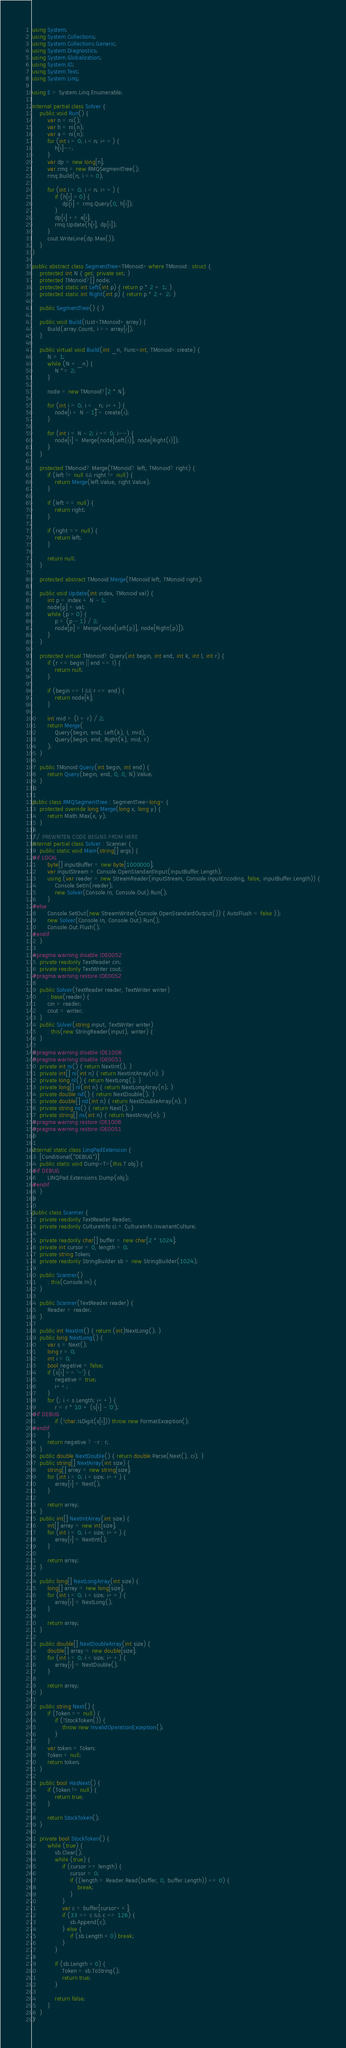<code> <loc_0><loc_0><loc_500><loc_500><_C#_>using System;
using System.Collections;
using System.Collections.Generic;
using System.Diagnostics;
using System.Globalization;
using System.IO;
using System.Text;
using System.Linq;

using E = System.Linq.Enumerable;

internal partial class Solver {
    public void Run() {
        var n = ni();
        var h = ni(n);
        var a = ni(n);
        for (int i = 0; i < n; i++) {
            h[i]--;
        }
        var dp = new long[n];
        var rmq = new RMQSegmentTree();
        rmq.Build(n, i => 0);

        for (int i = 0; i < n; i++) {
            if (h[i] > 0) {
                dp[i] = rmq.Query(0, h[i]);
            }
            dp[i] += a[i];
            rmq.Update(h[i], dp[i]);
        }
        cout.WriteLine(dp.Max());
    }
}

public abstract class SegmentTree<TMonoid> where TMonoid : struct {
    protected int N { get; private set; }
    protected TMonoid?[] node;
    protected static int Left(int p) { return p * 2 + 1; }
    protected static int Right(int p) { return p * 2 + 2; }

    public SegmentTree() { }

    public void Build(IList<TMonoid> array) {
        Build(array.Count, i => array[i]);
    }

    public virtual void Build(int _n, Func<int, TMonoid> create) {
        N = 1;
        while (N < _n) {
            N *= 2;
        }

        node = new TMonoid?[2 * N];

        for (int i = 0; i < _n; i++) {
            node[i + N - 1] = create(i);
        }

        for (int i = N - 2; i >= 0; i--) {
            node[i] = Merge(node[Left(i)], node[Right(i)]);
        }
    }

    protected TMonoid? Merge(TMonoid? left, TMonoid? right) {
        if (left != null && right != null) {
            return Merge(left.Value, right.Value);
        }

        if (left == null) {
            return right;
        }

        if (right == null) {
            return left;
        }

        return null;
    }

    protected abstract TMonoid Merge(TMonoid left, TMonoid right);

    public void Update(int index, TMonoid val) {
        int p = index + N - 1;
        node[p] = val;
        while (p > 0) {
            p = (p - 1) / 2;
            node[p] = Merge(node[Left(p)], node[Right(p)]);
        }
    }

    protected virtual TMonoid? Query(int begin, int end, int k, int l, int r) {
        if (r <= begin || end <= l) {
            return null;
        }

        if (begin <= l && r <= end) {
            return node[k];
        }

        int mid = (l + r) / 2;
        return Merge(
            Query(begin, end, Left(k), l, mid),
            Query(begin, end, Right(k), mid, r)
        );
    }

    public TMonoid Query(int begin, int end) {
        return Query(begin, end, 0, 0, N).Value;
    }
};

public class RMQSegmentTree : SegmentTree<long> {
    protected override long Merge(long x, long y) {
        return Math.Max(x, y);
    }
}
// PREWRITEN CODE BEGINS FROM HERE
internal partial class Solver : Scanner {
    public static void Main(string[] args) {
#if LOCAL
        byte[] inputBuffer = new byte[1000000];
        var inputStream = Console.OpenStandardInput(inputBuffer.Length);
        using (var reader = new StreamReader(inputStream, Console.InputEncoding, false, inputBuffer.Length)) {
            Console.SetIn(reader);
            new Solver(Console.In, Console.Out).Run();
        }
#else
        Console.SetOut(new StreamWriter(Console.OpenStandardOutput()) { AutoFlush = false });
        new Solver(Console.In, Console.Out).Run();
        Console.Out.Flush();
#endif
    }

#pragma warning disable IDE0052
    private readonly TextReader cin;
    private readonly TextWriter cout;
#pragma warning restore IDE0052

    public Solver(TextReader reader, TextWriter writer)
        : base(reader) {
        cin = reader;
        cout = writer;
    }
    public Solver(string input, TextWriter writer)
        : this(new StringReader(input), writer) {
    }

#pragma warning disable IDE1006
#pragma warning disable IDE0051
    private int ni() { return NextInt(); }
    private int[] ni(int n) { return NextIntArray(n); }
    private long nl() { return NextLong(); }
    private long[] nl(int n) { return NextLongArray(n); }
    private double nd() { return NextDouble(); }
    private double[] nd(int n) { return NextDoubleArray(n); }
    private string ns() { return Next(); }
    private string[] ns(int n) { return NextArray(n); }
#pragma warning restore IDE1006
#pragma warning restore IDE0051
}

internal static class LinqPadExtension {
    [Conditional("DEBUG")]
    public static void Dump<T>(this T obj) {
#if DEBUG
        LINQPad.Extensions.Dump(obj);
#endif
    }
}

public class Scanner {
    private readonly TextReader Reader;
    private readonly CultureInfo ci = CultureInfo.InvariantCulture;

    private readonly char[] buffer = new char[2 * 1024];
    private int cursor = 0, length = 0;
    private string Token;
    private readonly StringBuilder sb = new StringBuilder(1024);

    public Scanner()
        : this(Console.In) {
    }

    public Scanner(TextReader reader) {
        Reader = reader;
    }

    public int NextInt() { return (int)NextLong(); }
    public long NextLong() {
        var s = Next();
        long r = 0;
        int i = 0;
        bool negative = false;
        if (s[i] == '-') {
            negative = true;
            i++;
        }
        for (; i < s.Length; i++) {
            r = r * 10 + (s[i] - '0');
#if DEBUG
            if (!char.IsDigit(s[i])) throw new FormatException();
#endif
        }
        return negative ? -r : r;
    }
    public double NextDouble() { return double.Parse(Next(), ci); }
    public string[] NextArray(int size) {
        string[] array = new string[size];
        for (int i = 0; i < size; i++) {
            array[i] = Next();
        }

        return array;
    }
    public int[] NextIntArray(int size) {
        int[] array = new int[size];
        for (int i = 0; i < size; i++) {
            array[i] = NextInt();
        }

        return array;
    }

    public long[] NextLongArray(int size) {
        long[] array = new long[size];
        for (int i = 0; i < size; i++) {
            array[i] = NextLong();
        }

        return array;
    }

    public double[] NextDoubleArray(int size) {
        double[] array = new double[size];
        for (int i = 0; i < size; i++) {
            array[i] = NextDouble();
        }

        return array;
    }

    public string Next() {
        if (Token == null) {
            if (!StockToken()) {
                throw new InvalidOperationException();
            }
        }
        var token = Token;
        Token = null;
        return token;
    }

    public bool HasNext() {
        if (Token != null) {
            return true;
        }

        return StockToken();
    }

    private bool StockToken() {
        while (true) {
            sb.Clear();
            while (true) {
                if (cursor >= length) {
                    cursor = 0;
                    if ((length = Reader.Read(buffer, 0, buffer.Length)) <= 0) {
                        break;
                    }
                }
                var c = buffer[cursor++];
                if (33 <= c && c <= 126) {
                    sb.Append(c);
                } else {
                    if (sb.Length > 0) break;
                }
            }

            if (sb.Length > 0) {
                Token = sb.ToString();
                return true;
            }

            return false;
        }
    }
}</code> 